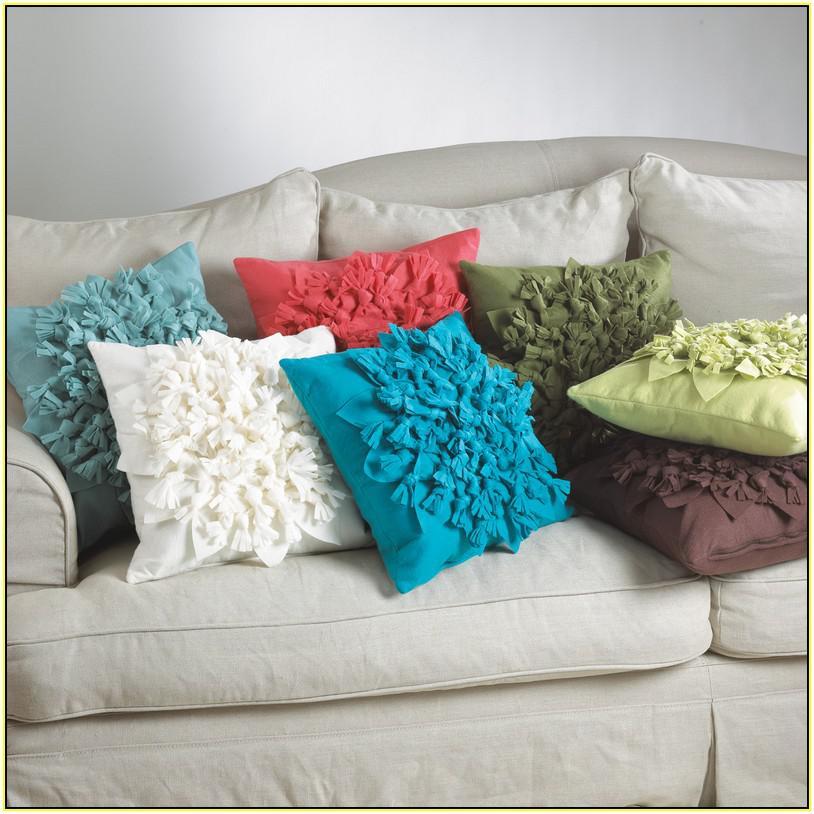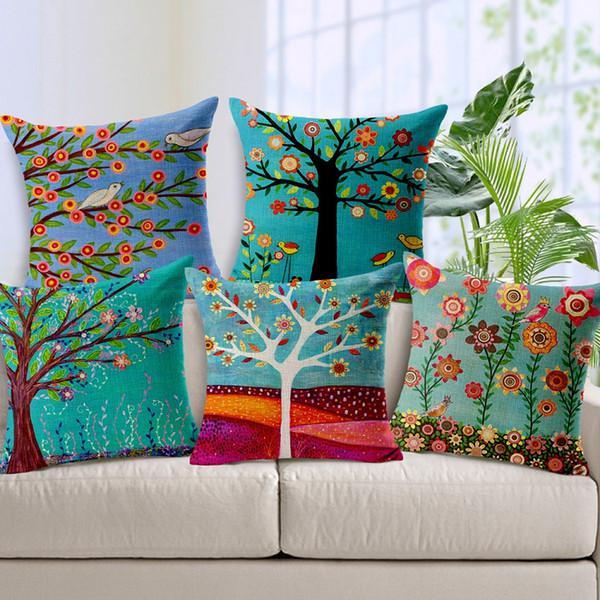The first image is the image on the left, the second image is the image on the right. Considering the images on both sides, is "Throw pillows are laid on a couch in each image." valid? Answer yes or no. Yes. The first image is the image on the left, the second image is the image on the right. Evaluate the accuracy of this statement regarding the images: "Each image shows at least three colorful throw pillows on a solid-colored sofa.". Is it true? Answer yes or no. Yes. 